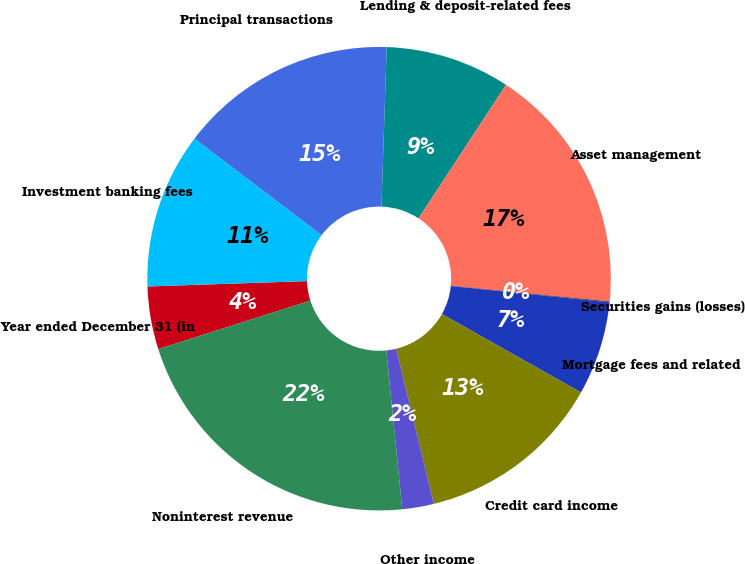Convert chart. <chart><loc_0><loc_0><loc_500><loc_500><pie_chart><fcel>Year ended December 31 (in<fcel>Investment banking fees<fcel>Principal transactions<fcel>Lending & deposit-related fees<fcel>Asset management<fcel>Securities gains (losses)<fcel>Mortgage fees and related<fcel>Credit card income<fcel>Other income<fcel>Noninterest revenue<nl><fcel>4.38%<fcel>10.87%<fcel>15.19%<fcel>8.7%<fcel>17.35%<fcel>0.05%<fcel>6.54%<fcel>13.03%<fcel>2.21%<fcel>21.68%<nl></chart> 